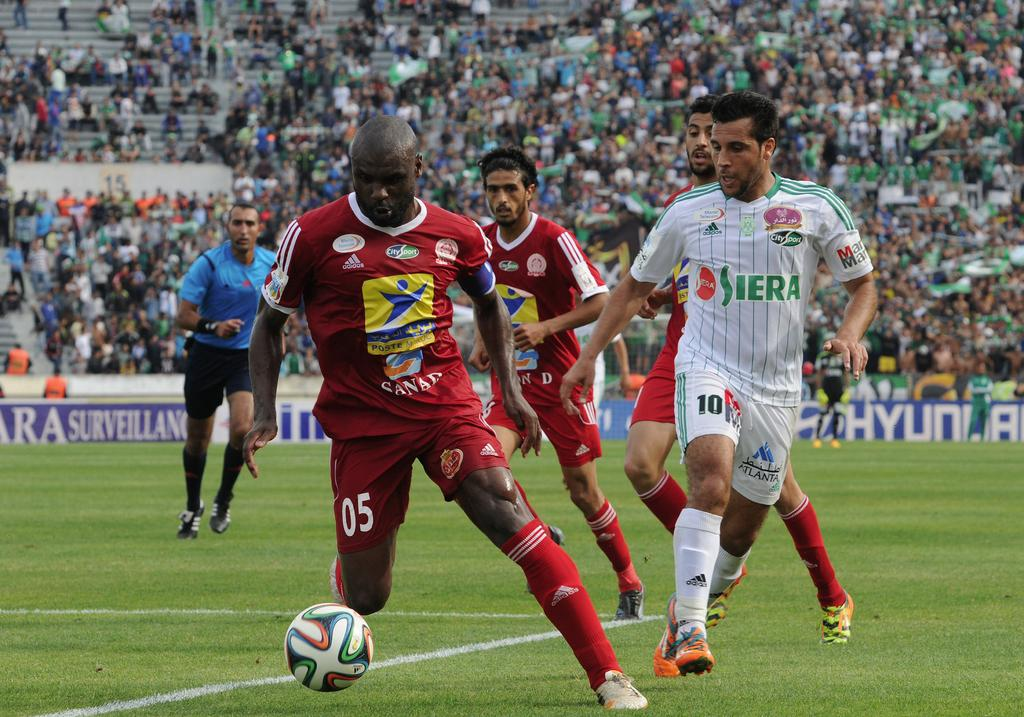<image>
Write a terse but informative summary of the picture. Adidas logo on a white Siera Jersey and a CitySport green logo. 